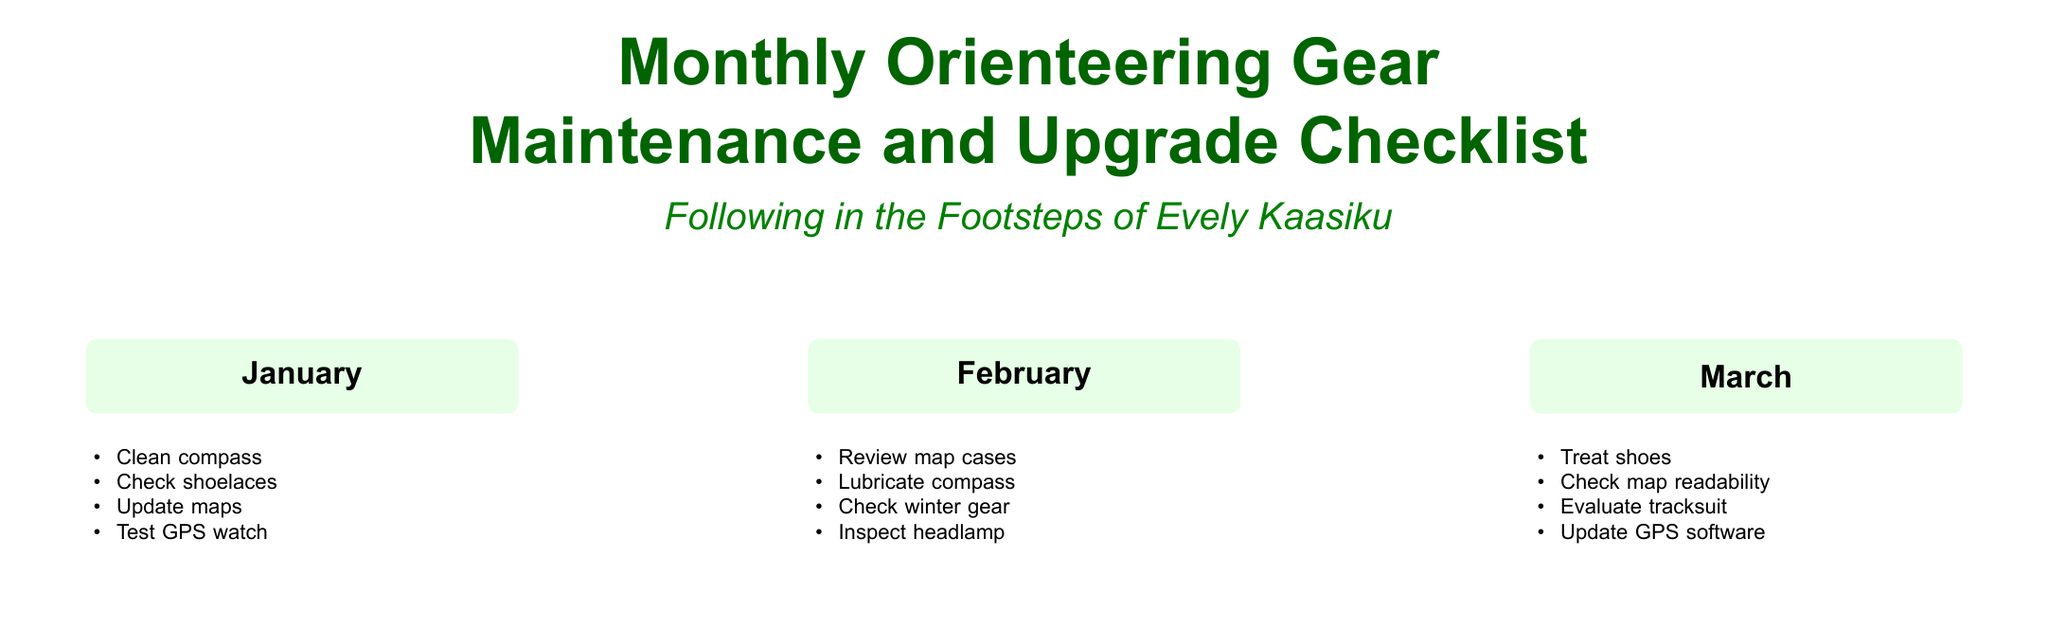what is the title of the document? The title of the document is found at the top of the rendered document, presenting the purpose clearly.
Answer: Monthly Orienteering Gear Maintenance and Upgrade Checklist how many months have gear tasks listed? There are twelve months mentioned in the checklist, each having specific tasks for gear maintenance and upgrades.
Answer: 12 which month includes the task to replace socks? The task to replace socks is listed under the month of April, indicating a seasonal focus.
Answer: April what is a task listed for June? One of the tasks for June involves cleaning all gear, emphasizing thorough maintenance during that month.
Answer: Clean all gear which item should be evaluated in March? The month of March includes the task to evaluate the tracksuit, indicating the importance of gear assessment.
Answer: Tracksuit how many tasks are listed for each month? Each month has four tasks, which creates a consistent structure across the document.
Answer: 4 which month focuses on upgrading gloves? The upgrade of gloves is scheduled for November according to the monthly tasks described.
Answer: November what should be done in December regarding event participation? In December, the task mentions registering for events, highlighting preparation for upcoming competitions.
Answer: Register for events 